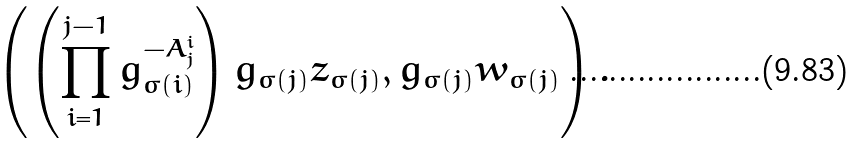Convert formula to latex. <formula><loc_0><loc_0><loc_500><loc_500>\left ( \left ( \prod _ { i = 1 } ^ { j - 1 } g _ { \sigma ( i ) } ^ { - A ^ { i } _ { j } } \right ) g _ { \sigma ( j ) } z _ { \sigma ( j ) } , g _ { \sigma ( j ) } w _ { \sigma ( j ) } \right ) .</formula> 